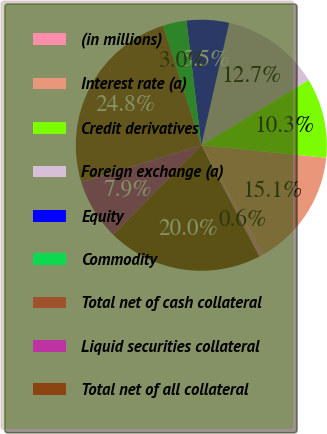Convert chart. <chart><loc_0><loc_0><loc_500><loc_500><pie_chart><fcel>(in millions)<fcel>Interest rate (a)<fcel>Credit derivatives<fcel>Foreign exchange (a)<fcel>Equity<fcel>Commodity<fcel>Total net of cash collateral<fcel>Liquid securities collateral<fcel>Total net of all collateral<nl><fcel>0.62%<fcel>15.14%<fcel>10.3%<fcel>12.72%<fcel>5.46%<fcel>3.04%<fcel>24.82%<fcel>7.88%<fcel>20.02%<nl></chart> 